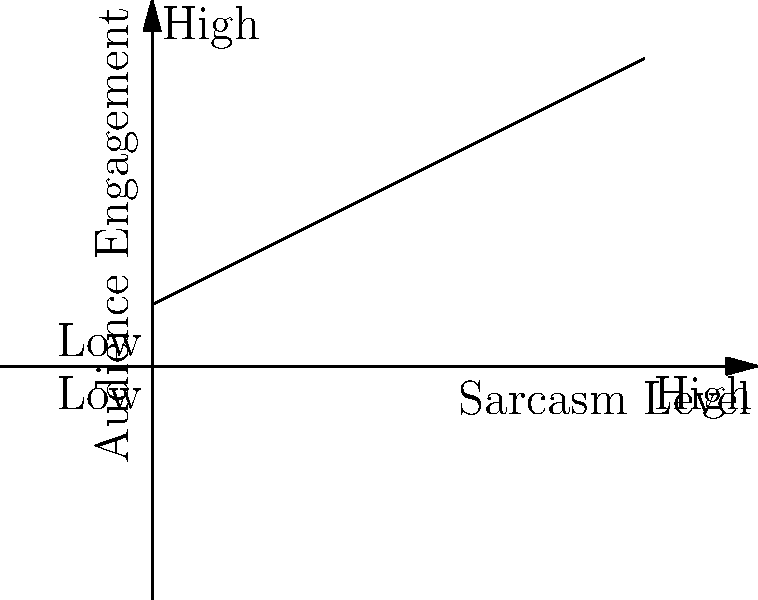As a freelance writer known for your sarcastic comments on controversial issues, you've been tracking the relationship between your level of sarcasm and audience engagement. The line graph above represents this relationship. Based on the trend shown, what can you conclude about the correlation between sarcasm usage and audience engagement? To answer this question, let's analyze the graph step-by-step:

1. Observe the axes:
   - X-axis represents "Sarcasm Level" from low to high
   - Y-axis represents "Audience Engagement" from low to high

2. Examine the line:
   - The line starts at the bottom-left (low sarcasm, low engagement)
   - It moves towards the top-right (high sarcasm, high engagement)

3. Interpret the trend:
   - As the sarcasm level increases, the audience engagement also increases
   - The relationship appears to be linear and positive

4. Consider the context:
   - As a freelance writer who sarcastically comments on controversial issues, this trend suggests that your audience responds positively to your sarcastic style

5. Draw a conclusion:
   - There is a positive correlation between sarcasm usage and audience engagement
   - Increased use of sarcasm in your writing tends to result in higher audience engagement

This trend aligns with your persona as a writer who uses sarcasm to comment on controversial issues, suggesting that your audience appreciates and engages more with your sarcastic style.
Answer: Positive correlation 